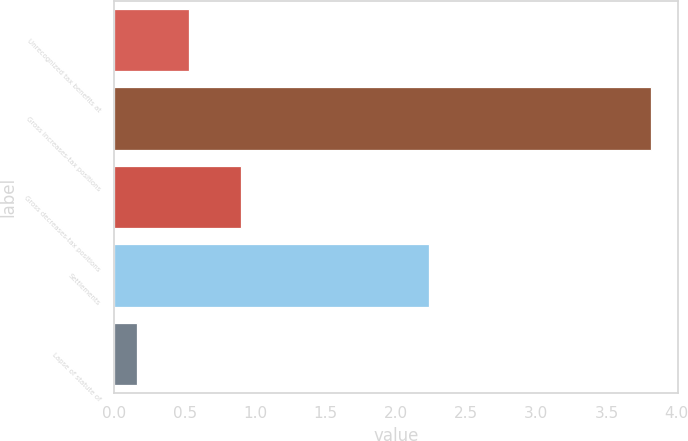Convert chart to OTSL. <chart><loc_0><loc_0><loc_500><loc_500><bar_chart><fcel>Unrecognized tax benefits at<fcel>Gross increases-tax positions<fcel>Gross decreases-tax positions<fcel>Settlements<fcel>Lapse of statute of<nl><fcel>0.53<fcel>3.82<fcel>0.9<fcel>2.24<fcel>0.16<nl></chart> 